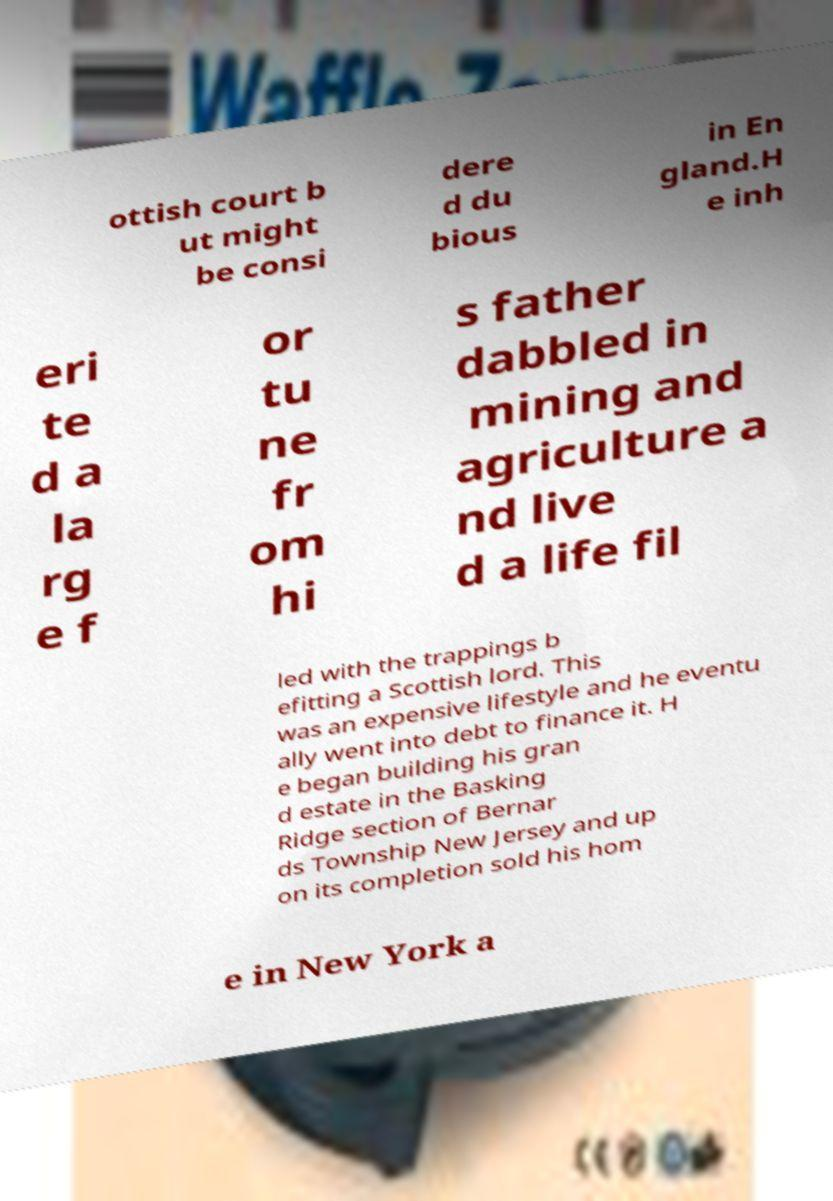For documentation purposes, I need the text within this image transcribed. Could you provide that? ottish court b ut might be consi dere d du bious in En gland.H e inh eri te d a la rg e f or tu ne fr om hi s father dabbled in mining and agriculture a nd live d a life fil led with the trappings b efitting a Scottish lord. This was an expensive lifestyle and he eventu ally went into debt to finance it. H e began building his gran d estate in the Basking Ridge section of Bernar ds Township New Jersey and up on its completion sold his hom e in New York a 